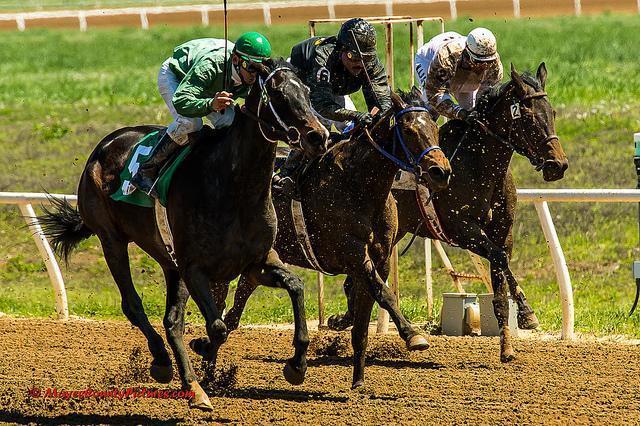How many people are visible?
Give a very brief answer. 3. How many horses are visible?
Give a very brief answer. 3. 